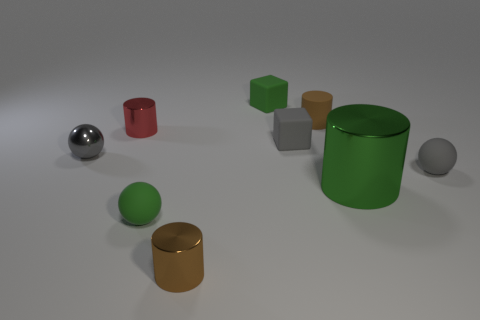Are there any other things that have the same size as the green shiny thing?
Make the answer very short. No. There is a brown cylinder that is in front of the rubber sphere right of the green matte block; how many brown cylinders are right of it?
Your answer should be very brief. 1. What number of tiny rubber objects are both to the right of the big metallic thing and in front of the large green thing?
Your answer should be very brief. 0. There is a thing that is the same color as the matte cylinder; what shape is it?
Your answer should be compact. Cylinder. Are the big green object and the tiny green ball made of the same material?
Give a very brief answer. No. The tiny thing right of the tiny brown cylinder behind the tiny rubber thing right of the brown rubber object is what shape?
Provide a succinct answer. Sphere. Is the number of gray rubber balls in front of the big object less than the number of tiny matte objects to the right of the small gray cube?
Your answer should be very brief. Yes. The gray rubber object that is behind the tiny object to the left of the red metallic thing is what shape?
Ensure brevity in your answer.  Cube. Is there anything else that has the same color as the large metal thing?
Ensure brevity in your answer.  Yes. Does the large cylinder have the same color as the small matte cylinder?
Your answer should be very brief. No. 